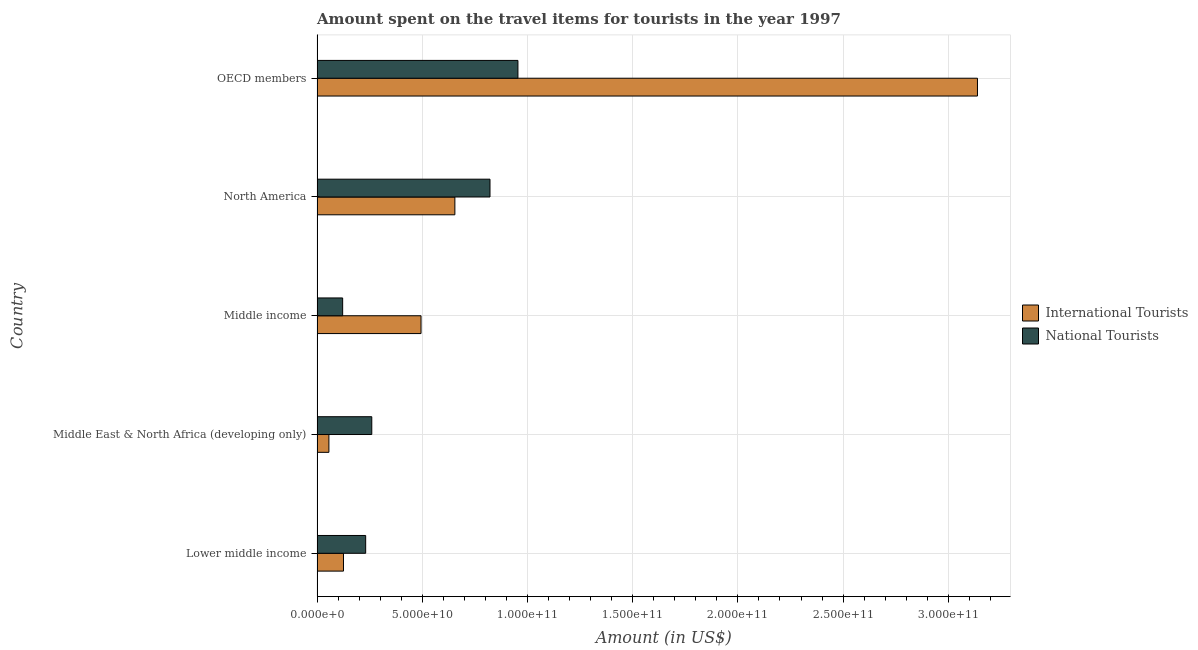Are the number of bars on each tick of the Y-axis equal?
Your response must be concise. Yes. How many bars are there on the 3rd tick from the top?
Make the answer very short. 2. How many bars are there on the 3rd tick from the bottom?
Ensure brevity in your answer.  2. What is the label of the 4th group of bars from the top?
Make the answer very short. Middle East & North Africa (developing only). What is the amount spent on travel items of national tourists in Lower middle income?
Your response must be concise. 2.31e+1. Across all countries, what is the maximum amount spent on travel items of international tourists?
Your answer should be very brief. 3.14e+11. Across all countries, what is the minimum amount spent on travel items of national tourists?
Your answer should be very brief. 1.22e+1. What is the total amount spent on travel items of international tourists in the graph?
Offer a terse response. 4.47e+11. What is the difference between the amount spent on travel items of international tourists in Middle East & North Africa (developing only) and that in OECD members?
Provide a short and direct response. -3.08e+11. What is the difference between the amount spent on travel items of international tourists in Middle income and the amount spent on travel items of national tourists in Middle East & North Africa (developing only)?
Your answer should be very brief. 2.34e+1. What is the average amount spent on travel items of national tourists per country?
Provide a succinct answer. 4.78e+1. What is the difference between the amount spent on travel items of national tourists and amount spent on travel items of international tourists in Middle East & North Africa (developing only)?
Give a very brief answer. 2.04e+1. In how many countries, is the amount spent on travel items of international tourists greater than 160000000000 US$?
Make the answer very short. 1. What is the ratio of the amount spent on travel items of international tourists in Lower middle income to that in Middle East & North Africa (developing only)?
Your answer should be compact. 2.23. What is the difference between the highest and the second highest amount spent on travel items of international tourists?
Your answer should be compact. 2.48e+11. What is the difference between the highest and the lowest amount spent on travel items of national tourists?
Your response must be concise. 8.33e+1. Is the sum of the amount spent on travel items of international tourists in North America and OECD members greater than the maximum amount spent on travel items of national tourists across all countries?
Your answer should be very brief. Yes. What does the 2nd bar from the top in Lower middle income represents?
Your answer should be compact. International Tourists. What does the 1st bar from the bottom in Lower middle income represents?
Provide a short and direct response. International Tourists. How many bars are there?
Offer a very short reply. 10. Where does the legend appear in the graph?
Your answer should be compact. Center right. What is the title of the graph?
Provide a succinct answer. Amount spent on the travel items for tourists in the year 1997. What is the label or title of the X-axis?
Your answer should be compact. Amount (in US$). What is the Amount (in US$) in International Tourists in Lower middle income?
Your response must be concise. 1.26e+1. What is the Amount (in US$) in National Tourists in Lower middle income?
Provide a short and direct response. 2.31e+1. What is the Amount (in US$) in International Tourists in Middle East & North Africa (developing only)?
Offer a very short reply. 5.64e+09. What is the Amount (in US$) of National Tourists in Middle East & North Africa (developing only)?
Your answer should be compact. 2.60e+1. What is the Amount (in US$) in International Tourists in Middle income?
Offer a terse response. 4.94e+1. What is the Amount (in US$) in National Tourists in Middle income?
Provide a short and direct response. 1.22e+1. What is the Amount (in US$) of International Tourists in North America?
Offer a terse response. 6.55e+1. What is the Amount (in US$) in National Tourists in North America?
Your response must be concise. 8.22e+1. What is the Amount (in US$) of International Tourists in OECD members?
Your answer should be compact. 3.14e+11. What is the Amount (in US$) of National Tourists in OECD members?
Make the answer very short. 9.55e+1. Across all countries, what is the maximum Amount (in US$) in International Tourists?
Your answer should be very brief. 3.14e+11. Across all countries, what is the maximum Amount (in US$) of National Tourists?
Give a very brief answer. 9.55e+1. Across all countries, what is the minimum Amount (in US$) in International Tourists?
Give a very brief answer. 5.64e+09. Across all countries, what is the minimum Amount (in US$) in National Tourists?
Your answer should be very brief. 1.22e+1. What is the total Amount (in US$) in International Tourists in the graph?
Make the answer very short. 4.47e+11. What is the total Amount (in US$) in National Tourists in the graph?
Give a very brief answer. 2.39e+11. What is the difference between the Amount (in US$) in International Tourists in Lower middle income and that in Middle East & North Africa (developing only)?
Provide a succinct answer. 6.93e+09. What is the difference between the Amount (in US$) of National Tourists in Lower middle income and that in Middle East & North Africa (developing only)?
Offer a terse response. -2.91e+09. What is the difference between the Amount (in US$) in International Tourists in Lower middle income and that in Middle income?
Ensure brevity in your answer.  -3.69e+1. What is the difference between the Amount (in US$) of National Tourists in Lower middle income and that in Middle income?
Offer a very short reply. 1.09e+1. What is the difference between the Amount (in US$) of International Tourists in Lower middle income and that in North America?
Make the answer very short. -5.29e+1. What is the difference between the Amount (in US$) of National Tourists in Lower middle income and that in North America?
Provide a short and direct response. -5.91e+1. What is the difference between the Amount (in US$) of International Tourists in Lower middle income and that in OECD members?
Make the answer very short. -3.01e+11. What is the difference between the Amount (in US$) in National Tourists in Lower middle income and that in OECD members?
Keep it short and to the point. -7.24e+1. What is the difference between the Amount (in US$) in International Tourists in Middle East & North Africa (developing only) and that in Middle income?
Provide a short and direct response. -4.38e+1. What is the difference between the Amount (in US$) in National Tourists in Middle East & North Africa (developing only) and that in Middle income?
Provide a succinct answer. 1.38e+1. What is the difference between the Amount (in US$) in International Tourists in Middle East & North Africa (developing only) and that in North America?
Give a very brief answer. -5.99e+1. What is the difference between the Amount (in US$) in National Tourists in Middle East & North Africa (developing only) and that in North America?
Ensure brevity in your answer.  -5.62e+1. What is the difference between the Amount (in US$) in International Tourists in Middle East & North Africa (developing only) and that in OECD members?
Offer a terse response. -3.08e+11. What is the difference between the Amount (in US$) in National Tourists in Middle East & North Africa (developing only) and that in OECD members?
Ensure brevity in your answer.  -6.95e+1. What is the difference between the Amount (in US$) of International Tourists in Middle income and that in North America?
Your response must be concise. -1.61e+1. What is the difference between the Amount (in US$) of National Tourists in Middle income and that in North America?
Provide a short and direct response. -7.00e+1. What is the difference between the Amount (in US$) of International Tourists in Middle income and that in OECD members?
Give a very brief answer. -2.64e+11. What is the difference between the Amount (in US$) in National Tourists in Middle income and that in OECD members?
Keep it short and to the point. -8.33e+1. What is the difference between the Amount (in US$) in International Tourists in North America and that in OECD members?
Give a very brief answer. -2.48e+11. What is the difference between the Amount (in US$) in National Tourists in North America and that in OECD members?
Your response must be concise. -1.33e+1. What is the difference between the Amount (in US$) in International Tourists in Lower middle income and the Amount (in US$) in National Tourists in Middle East & North Africa (developing only)?
Make the answer very short. -1.34e+1. What is the difference between the Amount (in US$) in International Tourists in Lower middle income and the Amount (in US$) in National Tourists in Middle income?
Your answer should be compact. 3.95e+08. What is the difference between the Amount (in US$) of International Tourists in Lower middle income and the Amount (in US$) of National Tourists in North America?
Keep it short and to the point. -6.96e+1. What is the difference between the Amount (in US$) in International Tourists in Lower middle income and the Amount (in US$) in National Tourists in OECD members?
Provide a succinct answer. -8.29e+1. What is the difference between the Amount (in US$) of International Tourists in Middle East & North Africa (developing only) and the Amount (in US$) of National Tourists in Middle income?
Provide a succinct answer. -6.53e+09. What is the difference between the Amount (in US$) of International Tourists in Middle East & North Africa (developing only) and the Amount (in US$) of National Tourists in North America?
Keep it short and to the point. -7.66e+1. What is the difference between the Amount (in US$) of International Tourists in Middle East & North Africa (developing only) and the Amount (in US$) of National Tourists in OECD members?
Offer a terse response. -8.98e+1. What is the difference between the Amount (in US$) in International Tourists in Middle income and the Amount (in US$) in National Tourists in North America?
Make the answer very short. -3.28e+1. What is the difference between the Amount (in US$) in International Tourists in Middle income and the Amount (in US$) in National Tourists in OECD members?
Provide a short and direct response. -4.61e+1. What is the difference between the Amount (in US$) of International Tourists in North America and the Amount (in US$) of National Tourists in OECD members?
Keep it short and to the point. -3.00e+1. What is the average Amount (in US$) of International Tourists per country?
Your answer should be very brief. 8.94e+1. What is the average Amount (in US$) of National Tourists per country?
Make the answer very short. 4.78e+1. What is the difference between the Amount (in US$) of International Tourists and Amount (in US$) of National Tourists in Lower middle income?
Keep it short and to the point. -1.05e+1. What is the difference between the Amount (in US$) of International Tourists and Amount (in US$) of National Tourists in Middle East & North Africa (developing only)?
Make the answer very short. -2.04e+1. What is the difference between the Amount (in US$) in International Tourists and Amount (in US$) in National Tourists in Middle income?
Make the answer very short. 3.72e+1. What is the difference between the Amount (in US$) in International Tourists and Amount (in US$) in National Tourists in North America?
Keep it short and to the point. -1.67e+1. What is the difference between the Amount (in US$) in International Tourists and Amount (in US$) in National Tourists in OECD members?
Keep it short and to the point. 2.18e+11. What is the ratio of the Amount (in US$) in International Tourists in Lower middle income to that in Middle East & North Africa (developing only)?
Give a very brief answer. 2.23. What is the ratio of the Amount (in US$) of National Tourists in Lower middle income to that in Middle East & North Africa (developing only)?
Your answer should be very brief. 0.89. What is the ratio of the Amount (in US$) in International Tourists in Lower middle income to that in Middle income?
Offer a very short reply. 0.25. What is the ratio of the Amount (in US$) of National Tourists in Lower middle income to that in Middle income?
Your answer should be compact. 1.9. What is the ratio of the Amount (in US$) in International Tourists in Lower middle income to that in North America?
Your answer should be compact. 0.19. What is the ratio of the Amount (in US$) of National Tourists in Lower middle income to that in North America?
Make the answer very short. 0.28. What is the ratio of the Amount (in US$) of National Tourists in Lower middle income to that in OECD members?
Your answer should be compact. 0.24. What is the ratio of the Amount (in US$) in International Tourists in Middle East & North Africa (developing only) to that in Middle income?
Your response must be concise. 0.11. What is the ratio of the Amount (in US$) in National Tourists in Middle East & North Africa (developing only) to that in Middle income?
Give a very brief answer. 2.14. What is the ratio of the Amount (in US$) in International Tourists in Middle East & North Africa (developing only) to that in North America?
Your response must be concise. 0.09. What is the ratio of the Amount (in US$) of National Tourists in Middle East & North Africa (developing only) to that in North America?
Your answer should be compact. 0.32. What is the ratio of the Amount (in US$) of International Tourists in Middle East & North Africa (developing only) to that in OECD members?
Offer a very short reply. 0.02. What is the ratio of the Amount (in US$) of National Tourists in Middle East & North Africa (developing only) to that in OECD members?
Provide a succinct answer. 0.27. What is the ratio of the Amount (in US$) in International Tourists in Middle income to that in North America?
Your response must be concise. 0.75. What is the ratio of the Amount (in US$) of National Tourists in Middle income to that in North America?
Offer a terse response. 0.15. What is the ratio of the Amount (in US$) of International Tourists in Middle income to that in OECD members?
Offer a terse response. 0.16. What is the ratio of the Amount (in US$) in National Tourists in Middle income to that in OECD members?
Provide a short and direct response. 0.13. What is the ratio of the Amount (in US$) in International Tourists in North America to that in OECD members?
Provide a succinct answer. 0.21. What is the ratio of the Amount (in US$) of National Tourists in North America to that in OECD members?
Offer a terse response. 0.86. What is the difference between the highest and the second highest Amount (in US$) of International Tourists?
Your answer should be very brief. 2.48e+11. What is the difference between the highest and the second highest Amount (in US$) in National Tourists?
Offer a very short reply. 1.33e+1. What is the difference between the highest and the lowest Amount (in US$) in International Tourists?
Offer a very short reply. 3.08e+11. What is the difference between the highest and the lowest Amount (in US$) of National Tourists?
Ensure brevity in your answer.  8.33e+1. 